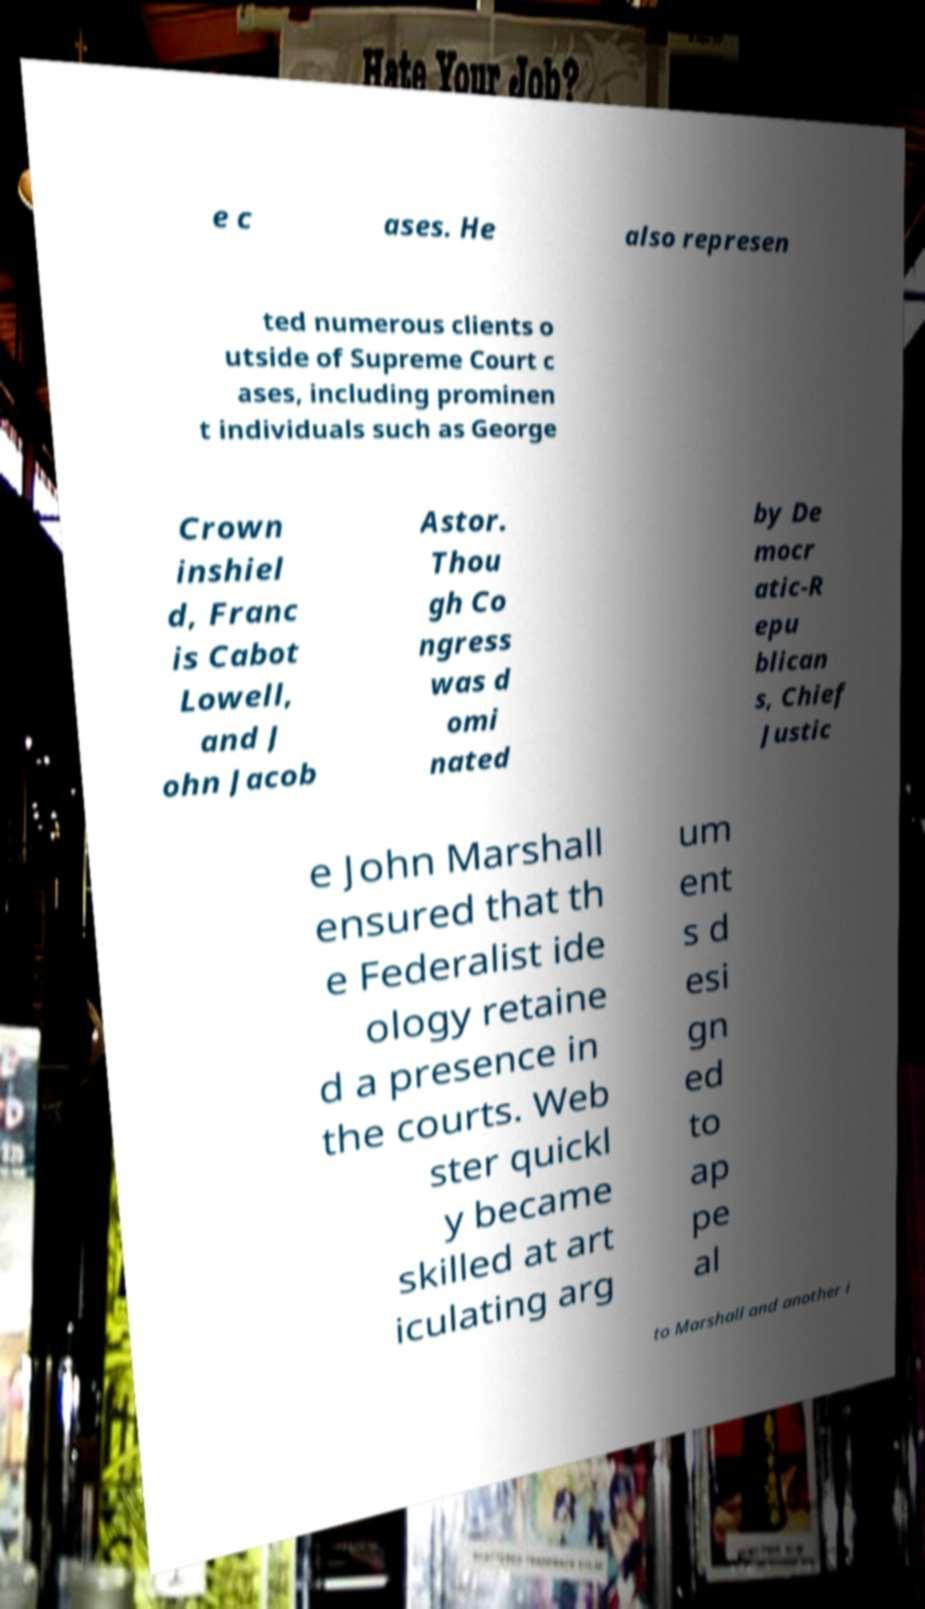Can you read and provide the text displayed in the image?This photo seems to have some interesting text. Can you extract and type it out for me? e c ases. He also represen ted numerous clients o utside of Supreme Court c ases, including prominen t individuals such as George Crown inshiel d, Franc is Cabot Lowell, and J ohn Jacob Astor. Thou gh Co ngress was d omi nated by De mocr atic-R epu blican s, Chief Justic e John Marshall ensured that th e Federalist ide ology retaine d a presence in the courts. Web ster quickl y became skilled at art iculating arg um ent s d esi gn ed to ap pe al to Marshall and another i 